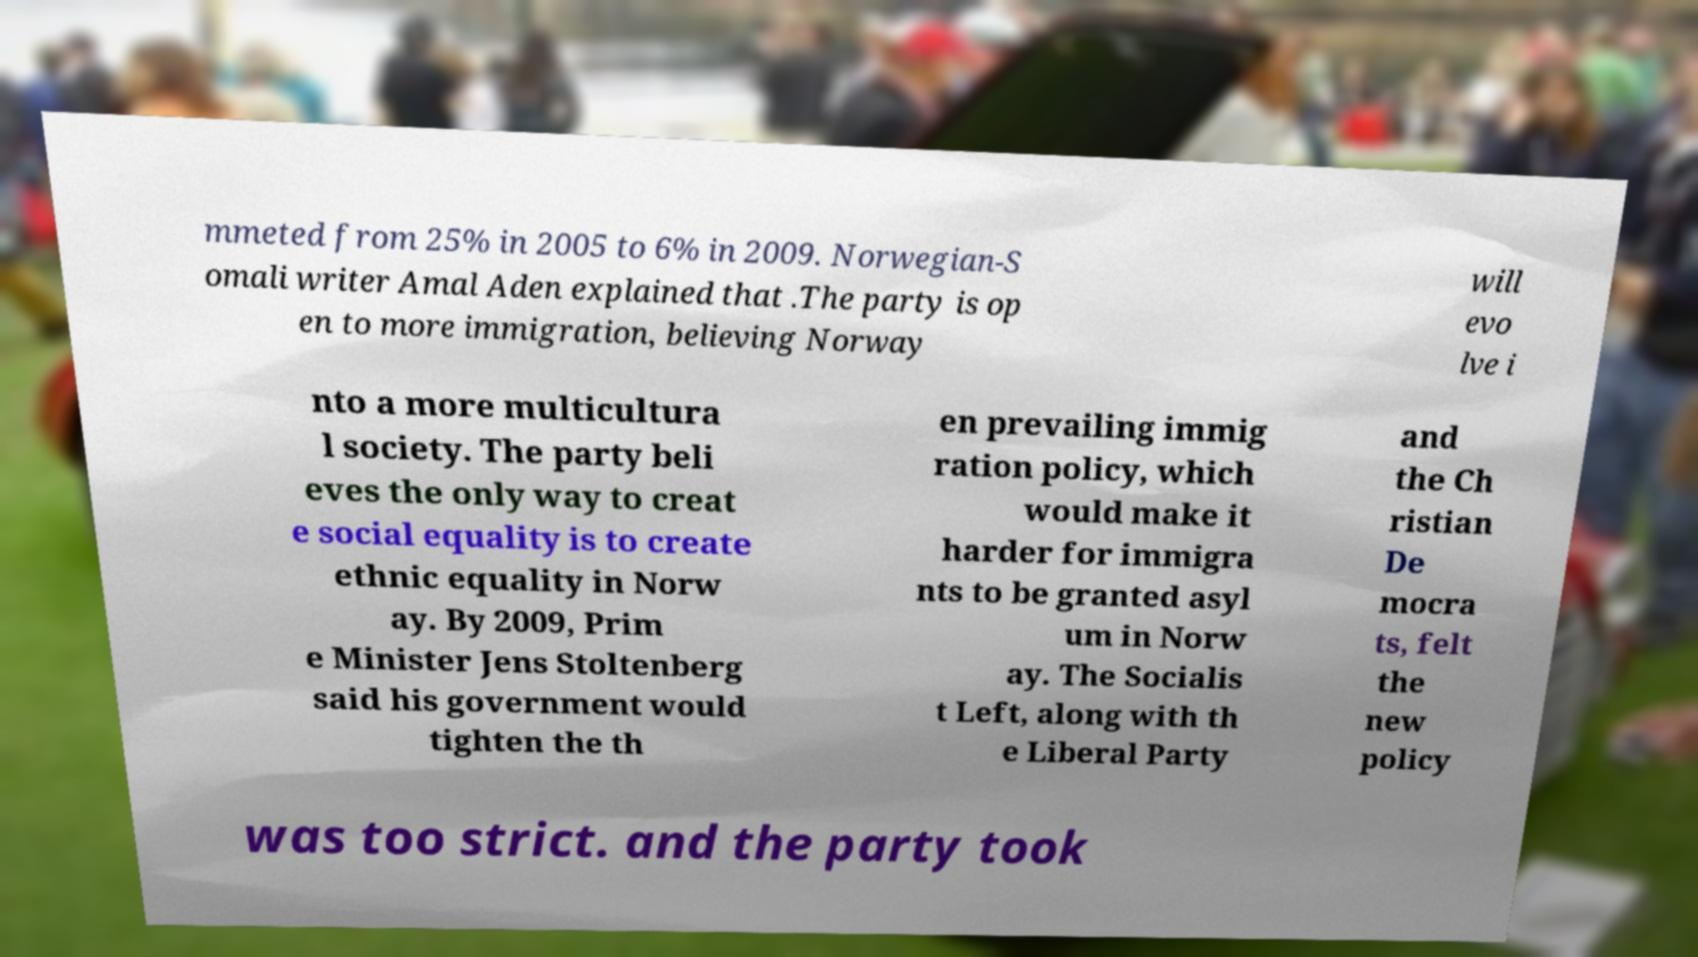Please read and relay the text visible in this image. What does it say? mmeted from 25% in 2005 to 6% in 2009. Norwegian-S omali writer Amal Aden explained that .The party is op en to more immigration, believing Norway will evo lve i nto a more multicultura l society. The party beli eves the only way to creat e social equality is to create ethnic equality in Norw ay. By 2009, Prim e Minister Jens Stoltenberg said his government would tighten the th en prevailing immig ration policy, which would make it harder for immigra nts to be granted asyl um in Norw ay. The Socialis t Left, along with th e Liberal Party and the Ch ristian De mocra ts, felt the new policy was too strict. and the party took 